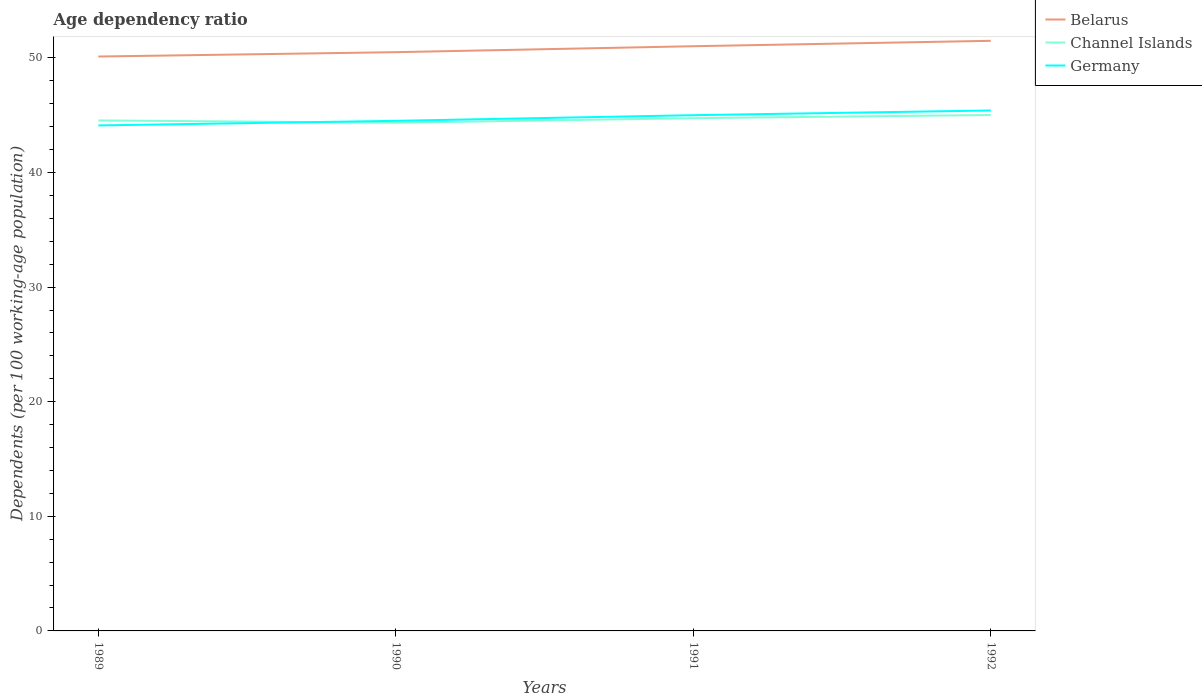How many different coloured lines are there?
Your answer should be compact. 3. Is the number of lines equal to the number of legend labels?
Make the answer very short. Yes. Across all years, what is the maximum age dependency ratio in in Channel Islands?
Keep it short and to the point. 44.34. In which year was the age dependency ratio in in Belarus maximum?
Make the answer very short. 1989. What is the total age dependency ratio in in Germany in the graph?
Your response must be concise. -0.9. What is the difference between the highest and the second highest age dependency ratio in in Channel Islands?
Offer a terse response. 0.67. Is the age dependency ratio in in Channel Islands strictly greater than the age dependency ratio in in Belarus over the years?
Ensure brevity in your answer.  Yes. How many lines are there?
Provide a succinct answer. 3. How many years are there in the graph?
Your answer should be very brief. 4. Are the values on the major ticks of Y-axis written in scientific E-notation?
Give a very brief answer. No. Does the graph contain any zero values?
Keep it short and to the point. No. What is the title of the graph?
Provide a succinct answer. Age dependency ratio. Does "Myanmar" appear as one of the legend labels in the graph?
Your answer should be very brief. No. What is the label or title of the X-axis?
Give a very brief answer. Years. What is the label or title of the Y-axis?
Keep it short and to the point. Dependents (per 100 working-age population). What is the Dependents (per 100 working-age population) in Belarus in 1989?
Offer a very short reply. 50.12. What is the Dependents (per 100 working-age population) of Channel Islands in 1989?
Make the answer very short. 44.54. What is the Dependents (per 100 working-age population) of Germany in 1989?
Provide a short and direct response. 44.11. What is the Dependents (per 100 working-age population) in Belarus in 1990?
Your response must be concise. 50.5. What is the Dependents (per 100 working-age population) of Channel Islands in 1990?
Offer a very short reply. 44.34. What is the Dependents (per 100 working-age population) of Germany in 1990?
Ensure brevity in your answer.  44.51. What is the Dependents (per 100 working-age population) in Belarus in 1991?
Keep it short and to the point. 51.02. What is the Dependents (per 100 working-age population) in Channel Islands in 1991?
Your answer should be compact. 44.74. What is the Dependents (per 100 working-age population) in Germany in 1991?
Your answer should be very brief. 45. What is the Dependents (per 100 working-age population) of Belarus in 1992?
Give a very brief answer. 51.49. What is the Dependents (per 100 working-age population) of Channel Islands in 1992?
Make the answer very short. 45.02. What is the Dependents (per 100 working-age population) in Germany in 1992?
Your response must be concise. 45.41. Across all years, what is the maximum Dependents (per 100 working-age population) in Belarus?
Ensure brevity in your answer.  51.49. Across all years, what is the maximum Dependents (per 100 working-age population) in Channel Islands?
Provide a short and direct response. 45.02. Across all years, what is the maximum Dependents (per 100 working-age population) of Germany?
Offer a terse response. 45.41. Across all years, what is the minimum Dependents (per 100 working-age population) of Belarus?
Your answer should be very brief. 50.12. Across all years, what is the minimum Dependents (per 100 working-age population) of Channel Islands?
Ensure brevity in your answer.  44.34. Across all years, what is the minimum Dependents (per 100 working-age population) of Germany?
Ensure brevity in your answer.  44.11. What is the total Dependents (per 100 working-age population) in Belarus in the graph?
Your answer should be compact. 203.12. What is the total Dependents (per 100 working-age population) of Channel Islands in the graph?
Your answer should be compact. 178.64. What is the total Dependents (per 100 working-age population) in Germany in the graph?
Give a very brief answer. 179.03. What is the difference between the Dependents (per 100 working-age population) of Belarus in 1989 and that in 1990?
Give a very brief answer. -0.38. What is the difference between the Dependents (per 100 working-age population) of Channel Islands in 1989 and that in 1990?
Keep it short and to the point. 0.2. What is the difference between the Dependents (per 100 working-age population) in Germany in 1989 and that in 1990?
Your answer should be compact. -0.4. What is the difference between the Dependents (per 100 working-age population) in Belarus in 1989 and that in 1991?
Your answer should be very brief. -0.9. What is the difference between the Dependents (per 100 working-age population) in Channel Islands in 1989 and that in 1991?
Make the answer very short. -0.2. What is the difference between the Dependents (per 100 working-age population) of Germany in 1989 and that in 1991?
Give a very brief answer. -0.89. What is the difference between the Dependents (per 100 working-age population) in Belarus in 1989 and that in 1992?
Keep it short and to the point. -1.37. What is the difference between the Dependents (per 100 working-age population) of Channel Islands in 1989 and that in 1992?
Your answer should be very brief. -0.47. What is the difference between the Dependents (per 100 working-age population) in Germany in 1989 and that in 1992?
Your answer should be compact. -1.31. What is the difference between the Dependents (per 100 working-age population) of Belarus in 1990 and that in 1991?
Your response must be concise. -0.52. What is the difference between the Dependents (per 100 working-age population) of Channel Islands in 1990 and that in 1991?
Your answer should be very brief. -0.4. What is the difference between the Dependents (per 100 working-age population) of Germany in 1990 and that in 1991?
Offer a very short reply. -0.49. What is the difference between the Dependents (per 100 working-age population) in Belarus in 1990 and that in 1992?
Ensure brevity in your answer.  -0.99. What is the difference between the Dependents (per 100 working-age population) of Channel Islands in 1990 and that in 1992?
Provide a succinct answer. -0.67. What is the difference between the Dependents (per 100 working-age population) of Germany in 1990 and that in 1992?
Ensure brevity in your answer.  -0.9. What is the difference between the Dependents (per 100 working-age population) in Belarus in 1991 and that in 1992?
Your response must be concise. -0.47. What is the difference between the Dependents (per 100 working-age population) in Channel Islands in 1991 and that in 1992?
Keep it short and to the point. -0.28. What is the difference between the Dependents (per 100 working-age population) in Germany in 1991 and that in 1992?
Keep it short and to the point. -0.41. What is the difference between the Dependents (per 100 working-age population) in Belarus in 1989 and the Dependents (per 100 working-age population) in Channel Islands in 1990?
Your answer should be very brief. 5.77. What is the difference between the Dependents (per 100 working-age population) in Belarus in 1989 and the Dependents (per 100 working-age population) in Germany in 1990?
Give a very brief answer. 5.61. What is the difference between the Dependents (per 100 working-age population) in Channel Islands in 1989 and the Dependents (per 100 working-age population) in Germany in 1990?
Keep it short and to the point. 0.03. What is the difference between the Dependents (per 100 working-age population) of Belarus in 1989 and the Dependents (per 100 working-age population) of Channel Islands in 1991?
Offer a very short reply. 5.38. What is the difference between the Dependents (per 100 working-age population) of Belarus in 1989 and the Dependents (per 100 working-age population) of Germany in 1991?
Provide a short and direct response. 5.12. What is the difference between the Dependents (per 100 working-age population) in Channel Islands in 1989 and the Dependents (per 100 working-age population) in Germany in 1991?
Offer a very short reply. -0.46. What is the difference between the Dependents (per 100 working-age population) in Belarus in 1989 and the Dependents (per 100 working-age population) in Channel Islands in 1992?
Your answer should be very brief. 5.1. What is the difference between the Dependents (per 100 working-age population) in Belarus in 1989 and the Dependents (per 100 working-age population) in Germany in 1992?
Your answer should be very brief. 4.71. What is the difference between the Dependents (per 100 working-age population) of Channel Islands in 1989 and the Dependents (per 100 working-age population) of Germany in 1992?
Make the answer very short. -0.87. What is the difference between the Dependents (per 100 working-age population) of Belarus in 1990 and the Dependents (per 100 working-age population) of Channel Islands in 1991?
Give a very brief answer. 5.76. What is the difference between the Dependents (per 100 working-age population) of Belarus in 1990 and the Dependents (per 100 working-age population) of Germany in 1991?
Provide a succinct answer. 5.5. What is the difference between the Dependents (per 100 working-age population) of Channel Islands in 1990 and the Dependents (per 100 working-age population) of Germany in 1991?
Provide a succinct answer. -0.66. What is the difference between the Dependents (per 100 working-age population) in Belarus in 1990 and the Dependents (per 100 working-age population) in Channel Islands in 1992?
Give a very brief answer. 5.48. What is the difference between the Dependents (per 100 working-age population) in Belarus in 1990 and the Dependents (per 100 working-age population) in Germany in 1992?
Offer a very short reply. 5.09. What is the difference between the Dependents (per 100 working-age population) in Channel Islands in 1990 and the Dependents (per 100 working-age population) in Germany in 1992?
Your answer should be very brief. -1.07. What is the difference between the Dependents (per 100 working-age population) of Belarus in 1991 and the Dependents (per 100 working-age population) of Channel Islands in 1992?
Make the answer very short. 6. What is the difference between the Dependents (per 100 working-age population) in Belarus in 1991 and the Dependents (per 100 working-age population) in Germany in 1992?
Your answer should be very brief. 5.61. What is the difference between the Dependents (per 100 working-age population) of Channel Islands in 1991 and the Dependents (per 100 working-age population) of Germany in 1992?
Offer a terse response. -0.67. What is the average Dependents (per 100 working-age population) of Belarus per year?
Keep it short and to the point. 50.78. What is the average Dependents (per 100 working-age population) of Channel Islands per year?
Give a very brief answer. 44.66. What is the average Dependents (per 100 working-age population) of Germany per year?
Make the answer very short. 44.76. In the year 1989, what is the difference between the Dependents (per 100 working-age population) of Belarus and Dependents (per 100 working-age population) of Channel Islands?
Make the answer very short. 5.57. In the year 1989, what is the difference between the Dependents (per 100 working-age population) of Belarus and Dependents (per 100 working-age population) of Germany?
Offer a very short reply. 6.01. In the year 1989, what is the difference between the Dependents (per 100 working-age population) of Channel Islands and Dependents (per 100 working-age population) of Germany?
Your response must be concise. 0.44. In the year 1990, what is the difference between the Dependents (per 100 working-age population) of Belarus and Dependents (per 100 working-age population) of Channel Islands?
Provide a short and direct response. 6.15. In the year 1990, what is the difference between the Dependents (per 100 working-age population) in Belarus and Dependents (per 100 working-age population) in Germany?
Ensure brevity in your answer.  5.99. In the year 1990, what is the difference between the Dependents (per 100 working-age population) of Channel Islands and Dependents (per 100 working-age population) of Germany?
Give a very brief answer. -0.16. In the year 1991, what is the difference between the Dependents (per 100 working-age population) in Belarus and Dependents (per 100 working-age population) in Channel Islands?
Offer a terse response. 6.28. In the year 1991, what is the difference between the Dependents (per 100 working-age population) in Belarus and Dependents (per 100 working-age population) in Germany?
Your response must be concise. 6.02. In the year 1991, what is the difference between the Dependents (per 100 working-age population) in Channel Islands and Dependents (per 100 working-age population) in Germany?
Your answer should be very brief. -0.26. In the year 1992, what is the difference between the Dependents (per 100 working-age population) in Belarus and Dependents (per 100 working-age population) in Channel Islands?
Your answer should be very brief. 6.47. In the year 1992, what is the difference between the Dependents (per 100 working-age population) in Belarus and Dependents (per 100 working-age population) in Germany?
Provide a succinct answer. 6.08. In the year 1992, what is the difference between the Dependents (per 100 working-age population) in Channel Islands and Dependents (per 100 working-age population) in Germany?
Give a very brief answer. -0.4. What is the ratio of the Dependents (per 100 working-age population) of Belarus in 1989 to that in 1990?
Provide a short and direct response. 0.99. What is the ratio of the Dependents (per 100 working-age population) in Germany in 1989 to that in 1990?
Give a very brief answer. 0.99. What is the ratio of the Dependents (per 100 working-age population) in Belarus in 1989 to that in 1991?
Give a very brief answer. 0.98. What is the ratio of the Dependents (per 100 working-age population) in Germany in 1989 to that in 1991?
Give a very brief answer. 0.98. What is the ratio of the Dependents (per 100 working-age population) in Belarus in 1989 to that in 1992?
Your response must be concise. 0.97. What is the ratio of the Dependents (per 100 working-age population) in Channel Islands in 1989 to that in 1992?
Offer a very short reply. 0.99. What is the ratio of the Dependents (per 100 working-age population) of Germany in 1989 to that in 1992?
Your answer should be compact. 0.97. What is the ratio of the Dependents (per 100 working-age population) of Belarus in 1990 to that in 1991?
Your answer should be very brief. 0.99. What is the ratio of the Dependents (per 100 working-age population) in Channel Islands in 1990 to that in 1991?
Your answer should be compact. 0.99. What is the ratio of the Dependents (per 100 working-age population) in Belarus in 1990 to that in 1992?
Offer a terse response. 0.98. What is the ratio of the Dependents (per 100 working-age population) in Channel Islands in 1990 to that in 1992?
Provide a short and direct response. 0.98. What is the ratio of the Dependents (per 100 working-age population) in Germany in 1990 to that in 1992?
Make the answer very short. 0.98. What is the ratio of the Dependents (per 100 working-age population) of Channel Islands in 1991 to that in 1992?
Offer a very short reply. 0.99. What is the ratio of the Dependents (per 100 working-age population) of Germany in 1991 to that in 1992?
Offer a terse response. 0.99. What is the difference between the highest and the second highest Dependents (per 100 working-age population) in Belarus?
Ensure brevity in your answer.  0.47. What is the difference between the highest and the second highest Dependents (per 100 working-age population) of Channel Islands?
Provide a succinct answer. 0.28. What is the difference between the highest and the second highest Dependents (per 100 working-age population) of Germany?
Make the answer very short. 0.41. What is the difference between the highest and the lowest Dependents (per 100 working-age population) of Belarus?
Give a very brief answer. 1.37. What is the difference between the highest and the lowest Dependents (per 100 working-age population) in Channel Islands?
Provide a succinct answer. 0.67. What is the difference between the highest and the lowest Dependents (per 100 working-age population) of Germany?
Your answer should be very brief. 1.31. 